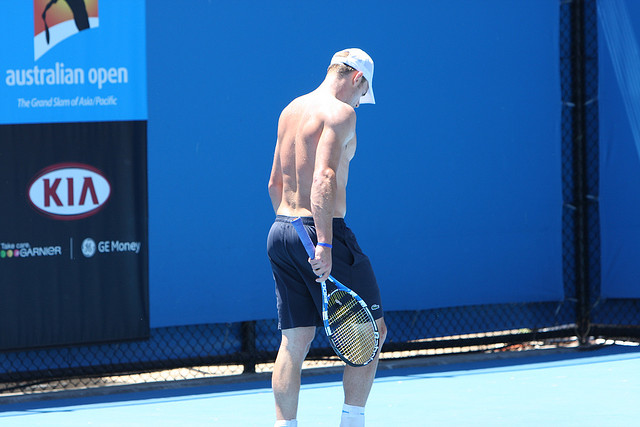Provide a long description of the player's preparation routine before a major event. In the week leading up to a major event like the Australian Open, the tennis player's routine is all about precision and balance. His mornings begin with light stretching before sunrise, followed by a nutrient-rich breakfast, usually consisting of complex carbohydrates, proteins, and plenty of hydration. Shortly after, he heads to the court for a rigorous practice session focusing on enhancing techniques such as serving accuracy, baseline control, and agile net play.

Post-practice, a period of recovery ensues, which often includes an ice bath to reduce muscle soreness, followed by guided yoga sessions to maintain flexibility and mental clarity. Nutritional intake is carefully monitored throughout the day, with meals designed to sustain energy levels, and snacks that aid in muscle repair.

Afternoons are reserved for strategy discussions with his coach, where they analyze potential opponents' playing styles and formulate game plans. This is coupled with additional on-court drills designed to replicate match conditions, sharpens his mental and physical reflexes.

Evenings are more relaxed, involving activities like reviewing game footage, studying tactics, and engaging in light physical exercises to keep the body active without overexertion. The day concludes with a hearty dinner focusing on lean proteins and vegetables, followed by a massage session to ensure muscles are at their peak condition.

Before sleeping, the player engages in mindfulness exercises, such as meditation or visualization techniques, envisioning successful plays and victories. This holistic routine, combining physical exertion, strategic planning, and mental conditioning, ensures he is in optimal shape as he steps out onto the court for the major event. 